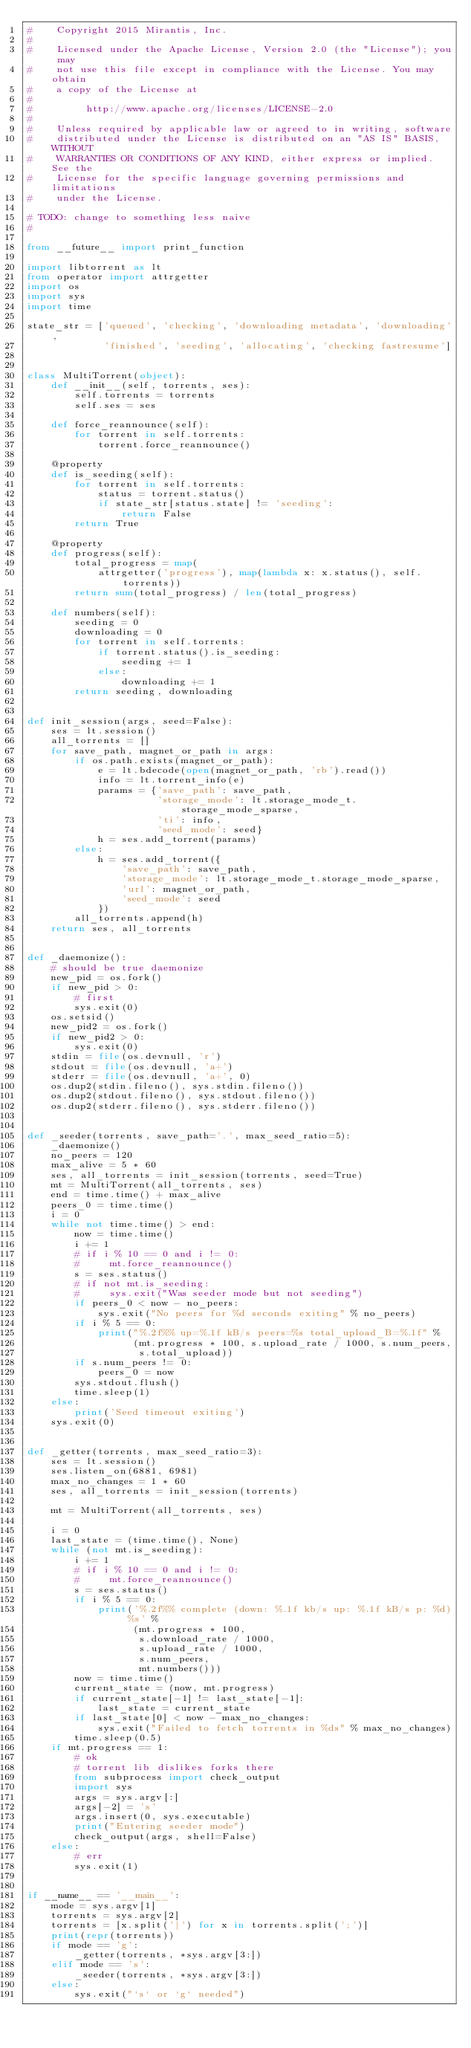<code> <loc_0><loc_0><loc_500><loc_500><_Python_>#    Copyright 2015 Mirantis, Inc.
#
#    Licensed under the Apache License, Version 2.0 (the "License"); you may
#    not use this file except in compliance with the License. You may obtain
#    a copy of the License at
#
#         http://www.apache.org/licenses/LICENSE-2.0
#
#    Unless required by applicable law or agreed to in writing, software
#    distributed under the License is distributed on an "AS IS" BASIS, WITHOUT
#    WARRANTIES OR CONDITIONS OF ANY KIND, either express or implied. See the
#    License for the specific language governing permissions and limitations
#    under the License.

# TODO: change to something less naive
#

from __future__ import print_function

import libtorrent as lt
from operator import attrgetter
import os
import sys
import time

state_str = ['queued', 'checking', 'downloading metadata', 'downloading',
             'finished', 'seeding', 'allocating', 'checking fastresume']


class MultiTorrent(object):
    def __init__(self, torrents, ses):
        self.torrents = torrents
        self.ses = ses

    def force_reannounce(self):
        for torrent in self.torrents:
            torrent.force_reannounce()

    @property
    def is_seeding(self):
        for torrent in self.torrents:
            status = torrent.status()
            if state_str[status.state] != 'seeding':
                return False
        return True

    @property
    def progress(self):
        total_progress = map(
            attrgetter('progress'), map(lambda x: x.status(), self.torrents))
        return sum(total_progress) / len(total_progress)

    def numbers(self):
        seeding = 0
        downloading = 0
        for torrent in self.torrents:
            if torrent.status().is_seeding:
                seeding += 1
            else:
                downloading += 1
        return seeding, downloading


def init_session(args, seed=False):
    ses = lt.session()
    all_torrents = []
    for save_path, magnet_or_path in args:
        if os.path.exists(magnet_or_path):
            e = lt.bdecode(open(magnet_or_path, 'rb').read())
            info = lt.torrent_info(e)
            params = {'save_path': save_path,
                      'storage_mode': lt.storage_mode_t.storage_mode_sparse,
                      'ti': info,
                      'seed_mode': seed}
            h = ses.add_torrent(params)
        else:
            h = ses.add_torrent({
                'save_path': save_path,
                'storage_mode': lt.storage_mode_t.storage_mode_sparse,
                'url': magnet_or_path,
                'seed_mode': seed
            })
        all_torrents.append(h)
    return ses, all_torrents


def _daemonize():
    # should be true daemonize
    new_pid = os.fork()
    if new_pid > 0:
        # first
        sys.exit(0)
    os.setsid()
    new_pid2 = os.fork()
    if new_pid2 > 0:
        sys.exit(0)
    stdin = file(os.devnull, 'r')
    stdout = file(os.devnull, 'a+')
    stderr = file(os.devnull, 'a+', 0)
    os.dup2(stdin.fileno(), sys.stdin.fileno())
    os.dup2(stdout.fileno(), sys.stdout.fileno())
    os.dup2(stderr.fileno(), sys.stderr.fileno())


def _seeder(torrents, save_path='.', max_seed_ratio=5):
    _daemonize()
    no_peers = 120
    max_alive = 5 * 60
    ses, all_torrents = init_session(torrents, seed=True)
    mt = MultiTorrent(all_torrents, ses)
    end = time.time() + max_alive
    peers_0 = time.time()
    i = 0
    while not time.time() > end:
        now = time.time()
        i += 1
        # if i % 10 == 0 and i != 0:
        #     mt.force_reannounce()
        s = ses.status()
        # if not mt.is_seeding:
        #     sys.exit("Was seeder mode but not seeding")
        if peers_0 < now - no_peers:
            sys.exit("No peers for %d seconds exiting" % no_peers)
        if i % 5 == 0:
            print("%.2f%% up=%.1f kB/s peers=%s total_upload_B=%.1f" %
                  (mt.progress * 100, s.upload_rate / 1000, s.num_peers,
                   s.total_upload))
        if s.num_peers != 0:
            peers_0 = now
        sys.stdout.flush()
        time.sleep(1)
    else:
        print('Seed timeout exiting')
    sys.exit(0)


def _getter(torrents, max_seed_ratio=3):
    ses = lt.session()
    ses.listen_on(6881, 6981)
    max_no_changes = 1 * 60
    ses, all_torrents = init_session(torrents)

    mt = MultiTorrent(all_torrents, ses)

    i = 0
    last_state = (time.time(), None)
    while (not mt.is_seeding):
        i += 1
        # if i % 10 == 0 and i != 0:
        #     mt.force_reannounce()
        s = ses.status()
        if i % 5 == 0:
            print('%.2f%% complete (down: %.1f kb/s up: %.1f kB/s p: %d) %s' %
                  (mt.progress * 100,
                   s.download_rate / 1000,
                   s.upload_rate / 1000,
                   s.num_peers,
                   mt.numbers()))
        now = time.time()
        current_state = (now, mt.progress)
        if current_state[-1] != last_state[-1]:
            last_state = current_state
        if last_state[0] < now - max_no_changes:
            sys.exit("Failed to fetch torrents in %ds" % max_no_changes)
        time.sleep(0.5)
    if mt.progress == 1:
        # ok
        # torrent lib dislikes forks there
        from subprocess import check_output
        import sys
        args = sys.argv[:]
        args[-2] = 's'
        args.insert(0, sys.executable)
        print("Entering seeder mode")
        check_output(args, shell=False)
    else:
        # err
        sys.exit(1)


if __name__ == '__main__':
    mode = sys.argv[1]
    torrents = sys.argv[2]
    torrents = [x.split('|') for x in torrents.split(';')]
    print(repr(torrents))
    if mode == 'g':
        _getter(torrents, *sys.argv[3:])
    elif mode == 's':
        _seeder(torrents, *sys.argv[3:])
    else:
        sys.exit("`s` or `g` needed")
</code> 